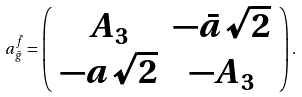Convert formula to latex. <formula><loc_0><loc_0><loc_500><loc_500>a _ { \bar { g } } ^ { \bar { f } } = \left ( \begin{array} { c c } { { A _ { 3 } } } & { { - \bar { a } \sqrt { 2 } } } \\ { { - a \sqrt { 2 } } } & { { - A _ { 3 } } } \end{array} \right ) .</formula> 